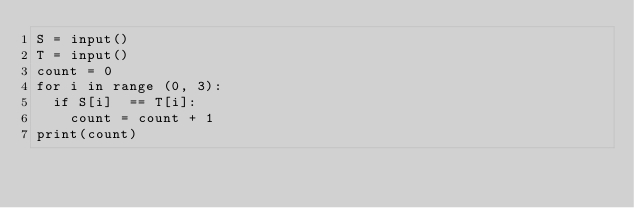Convert code to text. <code><loc_0><loc_0><loc_500><loc_500><_Python_>S = input()
T = input()
count = 0
for i in range (0, 3):
  if S[i]  == T[i]:
    count = count + 1
print(count)</code> 